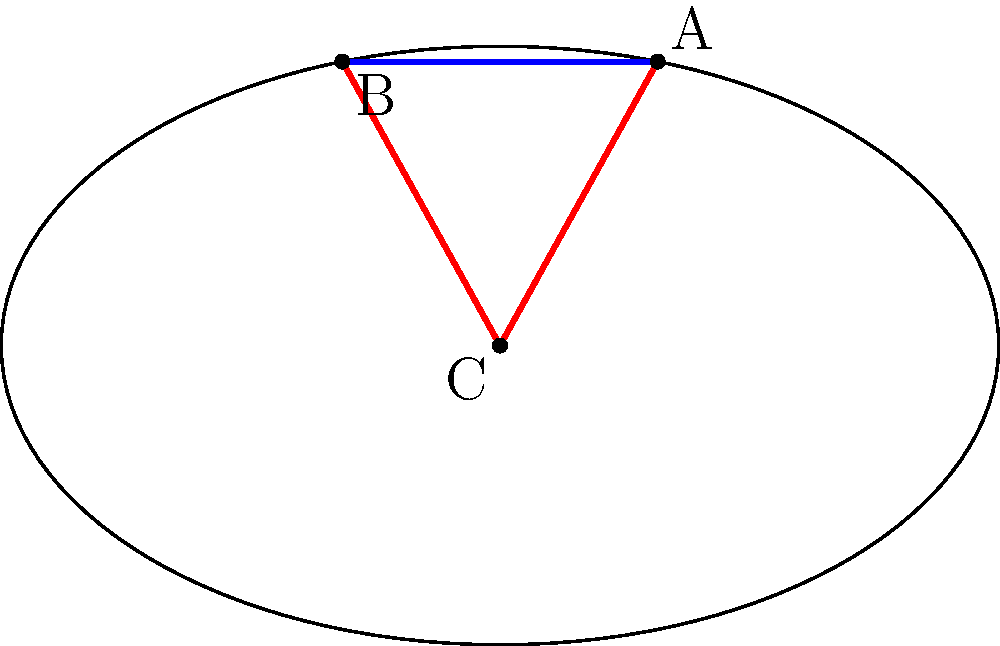As you approach a turn on the oval track, you need to calculate the angle of approach for optimal performance. Given that point A represents your current position, point B is the entry point of the turn, and point C is the center of the track, calculate the angle of approach (∠ACB) in degrees. Use the following coordinates:
A(80, 0), B(60, 48), C(0, 0). To find the angle of approach (∠ACB), we'll use the law of cosines. Here's the step-by-step solution:

1) First, calculate the lengths of the sides:
   AC = $\sqrt{80^2 + 0^2} = 80$
   BC = $\sqrt{60^2 + 48^2} = \sqrt{3600 + 2304} = \sqrt{5904} = 76.84$
   AB = $\sqrt{(80-60)^2 + (0-48)^2} = \sqrt{400 + 2304} = \sqrt{2704} = 52$

2) Now, use the law of cosines:
   $\cos(∠ACB) = \frac{AC^2 + BC^2 - AB^2}{2(AC)(BC)}$

3) Substitute the values:
   $\cos(∠ACB) = \frac{80^2 + 76.84^2 - 52^2}{2(80)(76.84)}$

4) Simplify:
   $\cos(∠ACB) = \frac{6400 + 5904.39 - 2704}{12294.4} = \frac{9600.39}{12294.4} = 0.7808$

5) Take the inverse cosine (arccos) of both sides:
   $∠ACB = \arccos(0.7808)$

6) Convert to degrees:
   $∠ACB = 38.68°$

Therefore, the angle of approach (∠ACB) is approximately 38.68°.
Answer: 38.68° 